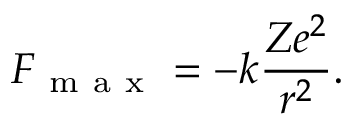<formula> <loc_0><loc_0><loc_500><loc_500>F _ { m a x } = - k \frac { Z e ^ { 2 } } { r ^ { 2 } } .</formula> 